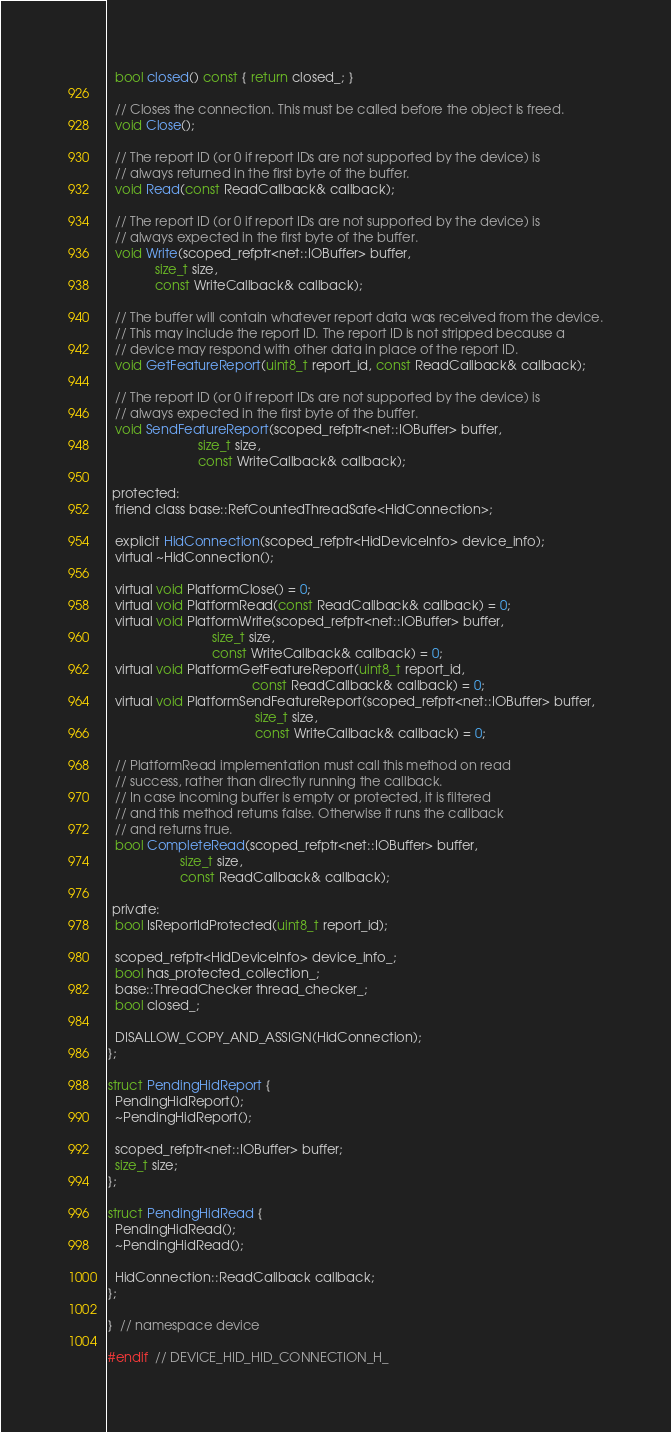Convert code to text. <code><loc_0><loc_0><loc_500><loc_500><_C_>  bool closed() const { return closed_; }

  // Closes the connection. This must be called before the object is freed.
  void Close();

  // The report ID (or 0 if report IDs are not supported by the device) is
  // always returned in the first byte of the buffer.
  void Read(const ReadCallback& callback);

  // The report ID (or 0 if report IDs are not supported by the device) is
  // always expected in the first byte of the buffer.
  void Write(scoped_refptr<net::IOBuffer> buffer,
             size_t size,
             const WriteCallback& callback);

  // The buffer will contain whatever report data was received from the device.
  // This may include the report ID. The report ID is not stripped because a
  // device may respond with other data in place of the report ID.
  void GetFeatureReport(uint8_t report_id, const ReadCallback& callback);

  // The report ID (or 0 if report IDs are not supported by the device) is
  // always expected in the first byte of the buffer.
  void SendFeatureReport(scoped_refptr<net::IOBuffer> buffer,
                         size_t size,
                         const WriteCallback& callback);

 protected:
  friend class base::RefCountedThreadSafe<HidConnection>;

  explicit HidConnection(scoped_refptr<HidDeviceInfo> device_info);
  virtual ~HidConnection();

  virtual void PlatformClose() = 0;
  virtual void PlatformRead(const ReadCallback& callback) = 0;
  virtual void PlatformWrite(scoped_refptr<net::IOBuffer> buffer,
                             size_t size,
                             const WriteCallback& callback) = 0;
  virtual void PlatformGetFeatureReport(uint8_t report_id,
                                        const ReadCallback& callback) = 0;
  virtual void PlatformSendFeatureReport(scoped_refptr<net::IOBuffer> buffer,
                                         size_t size,
                                         const WriteCallback& callback) = 0;

  // PlatformRead implementation must call this method on read
  // success, rather than directly running the callback.
  // In case incoming buffer is empty or protected, it is filtered
  // and this method returns false. Otherwise it runs the callback
  // and returns true.
  bool CompleteRead(scoped_refptr<net::IOBuffer> buffer,
                    size_t size,
                    const ReadCallback& callback);

 private:
  bool IsReportIdProtected(uint8_t report_id);

  scoped_refptr<HidDeviceInfo> device_info_;
  bool has_protected_collection_;
  base::ThreadChecker thread_checker_;
  bool closed_;

  DISALLOW_COPY_AND_ASSIGN(HidConnection);
};

struct PendingHidReport {
  PendingHidReport();
  ~PendingHidReport();

  scoped_refptr<net::IOBuffer> buffer;
  size_t size;
};

struct PendingHidRead {
  PendingHidRead();
  ~PendingHidRead();

  HidConnection::ReadCallback callback;
};

}  // namespace device

#endif  // DEVICE_HID_HID_CONNECTION_H_
</code> 